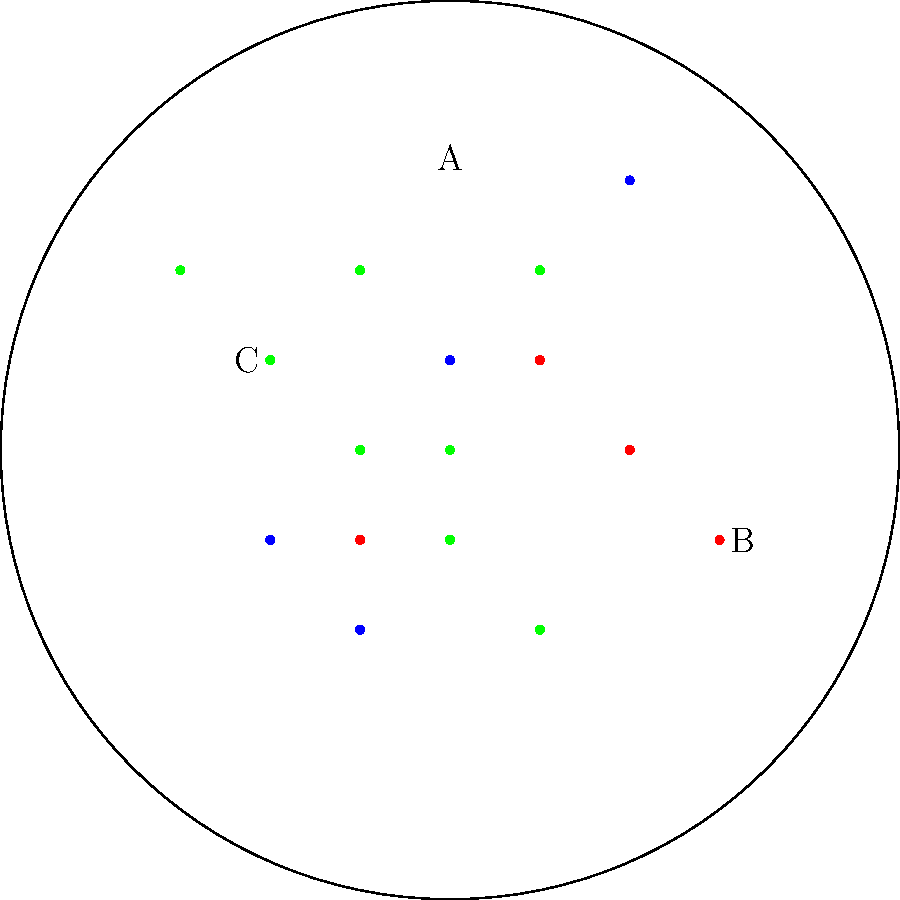During your stargazing adventure on a clear night, you observe a star map as shown above. Three constellations are highlighted in different colors: blue (A), red (B), and green (C). Which of these constellations is Cassiopeia? To identify Cassiopeia in the given star map, let's analyze each constellation:

1. Constellation A (blue):
   - Has 7 main stars
   - Forms a shape resembling a big dipper or a large spoon
   - This is likely Ursa Major (The Great Bear)

2. Constellation B (red):
   - Has 5 main stars
   - Forms a distinctive W or M shape
   - This characteristic shape is unique to Cassiopeia

3. Constellation C (green):
   - Has 8 main stars
   - Forms a shape resembling a human figure with a belt
   - This is likely Orion (The Hunter)

Based on these observations, we can conclude that Constellation B, marked in red, is Cassiopeia. It's known for its distinctive W or M shape, which is clearly visible in the star map.
Answer: B 